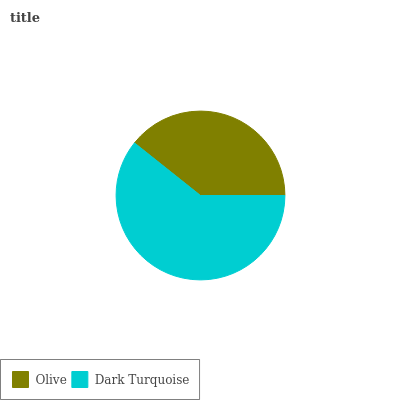Is Olive the minimum?
Answer yes or no. Yes. Is Dark Turquoise the maximum?
Answer yes or no. Yes. Is Dark Turquoise the minimum?
Answer yes or no. No. Is Dark Turquoise greater than Olive?
Answer yes or no. Yes. Is Olive less than Dark Turquoise?
Answer yes or no. Yes. Is Olive greater than Dark Turquoise?
Answer yes or no. No. Is Dark Turquoise less than Olive?
Answer yes or no. No. Is Dark Turquoise the high median?
Answer yes or no. Yes. Is Olive the low median?
Answer yes or no. Yes. Is Olive the high median?
Answer yes or no. No. Is Dark Turquoise the low median?
Answer yes or no. No. 